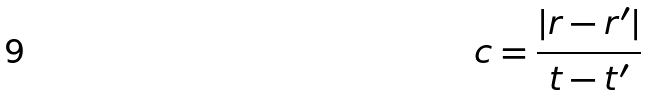Convert formula to latex. <formula><loc_0><loc_0><loc_500><loc_500>c = \frac { | r - r ^ { \prime } | } { t - t ^ { \prime } }</formula> 